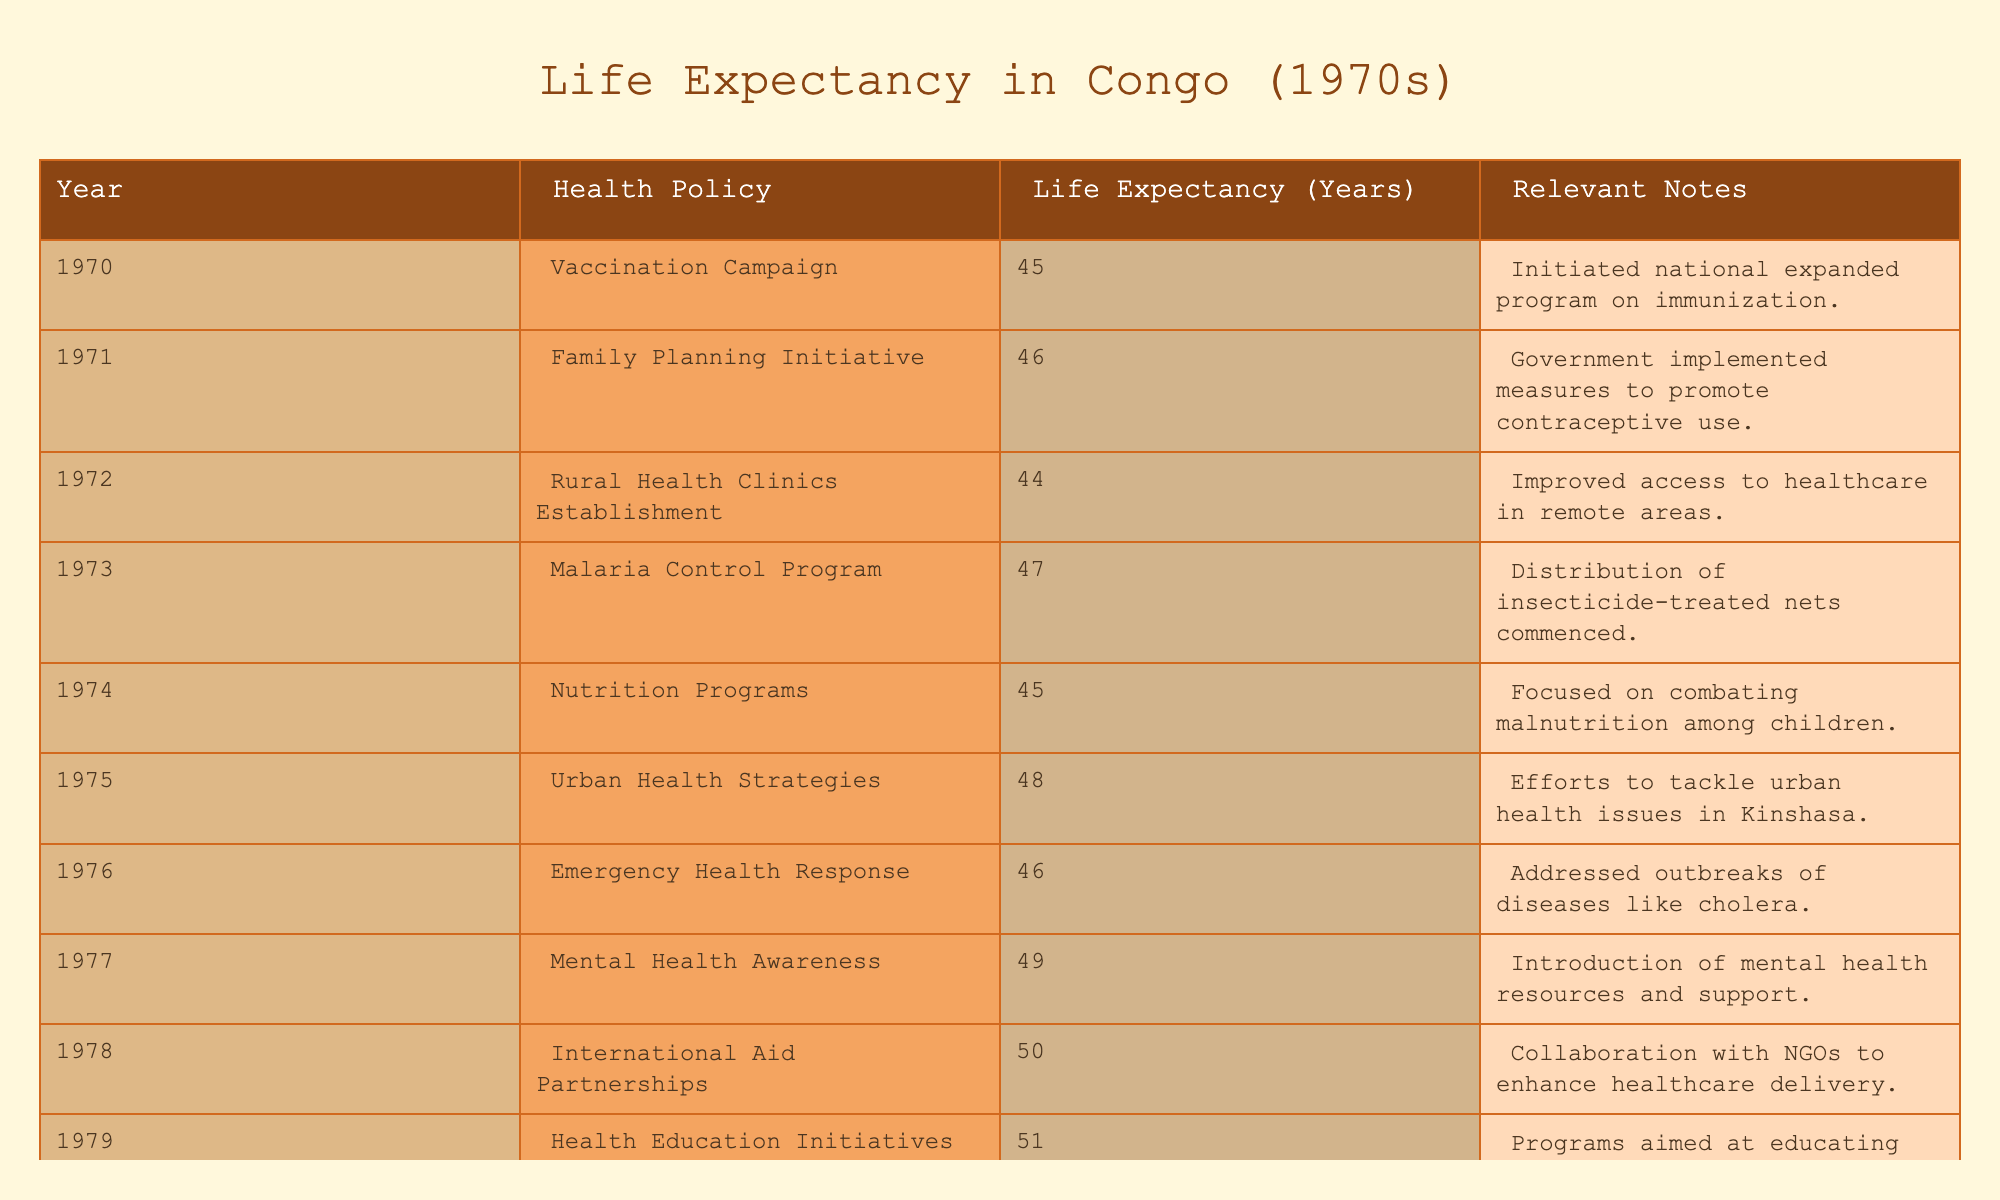What was the life expectancy in Congo in 1975? Referring directly to the table, the value for life expectancy in 1975 is listed under that year.
Answer: 48 Which health policy introduced in 1977 had the highest impact on life expectancy? The table shows that the "Mental Health Awareness" policy in 1977 increased life expectancy to 49 years, which is higher than the preceding years.
Answer: Mental Health Awareness What was the average life expectancy from 1970 to 1974? To find the average, add the life expectancies for each year (45 + 46 + 44 + 47 + 45) totaling 227. Then, divide by the number of years (5): 227 / 5 = 45.4.
Answer: 45.4 In what year did life expectancy first reach 50 years? Upon examining the table, life expectancy first reached 50 years in 1978.
Answer: 1978 Did the introduction of the Family Planning Initiative contribute to an increase in life expectancy from 1970 to 1971? By comparing the life expectancy values, it can be seen that it rose from 45 years in 1970 to 46 years in 1971, indicating a positive effect.
Answer: Yes What was the difference in life expectancy between the years 1976 and 1979? The life expectancy in 1976 was 46 years, and in 1979 it was 51 years. The difference is computed by subtracting 46 from 51, resulting in 5 years.
Answer: 5 years Which health policy had the lowest life expectancy effect in 1972? The "Rural Health Clinics Establishment" policy in 1972 had a life expectancy of 44 years, which is lower than all the other years listed.
Answer: Rural Health Clinics Establishment What was the trend of life expectancy from 1970 to 1979? A careful assessment of the life expectancy for each year shows a progressive increase, starting from 45 years in 1970 to 51 years in 1979, indicating a positive upward trend.
Answer: Increasing trend What was the role of international aid in the health policies of 1978? The table notes that in 1978, "International Aid Partnerships" was introduced alongside a life expectancy of 50 years, suggesting significant external contributions to health policies that may have impacted this metric.
Answer: Collaboration with NGOs 